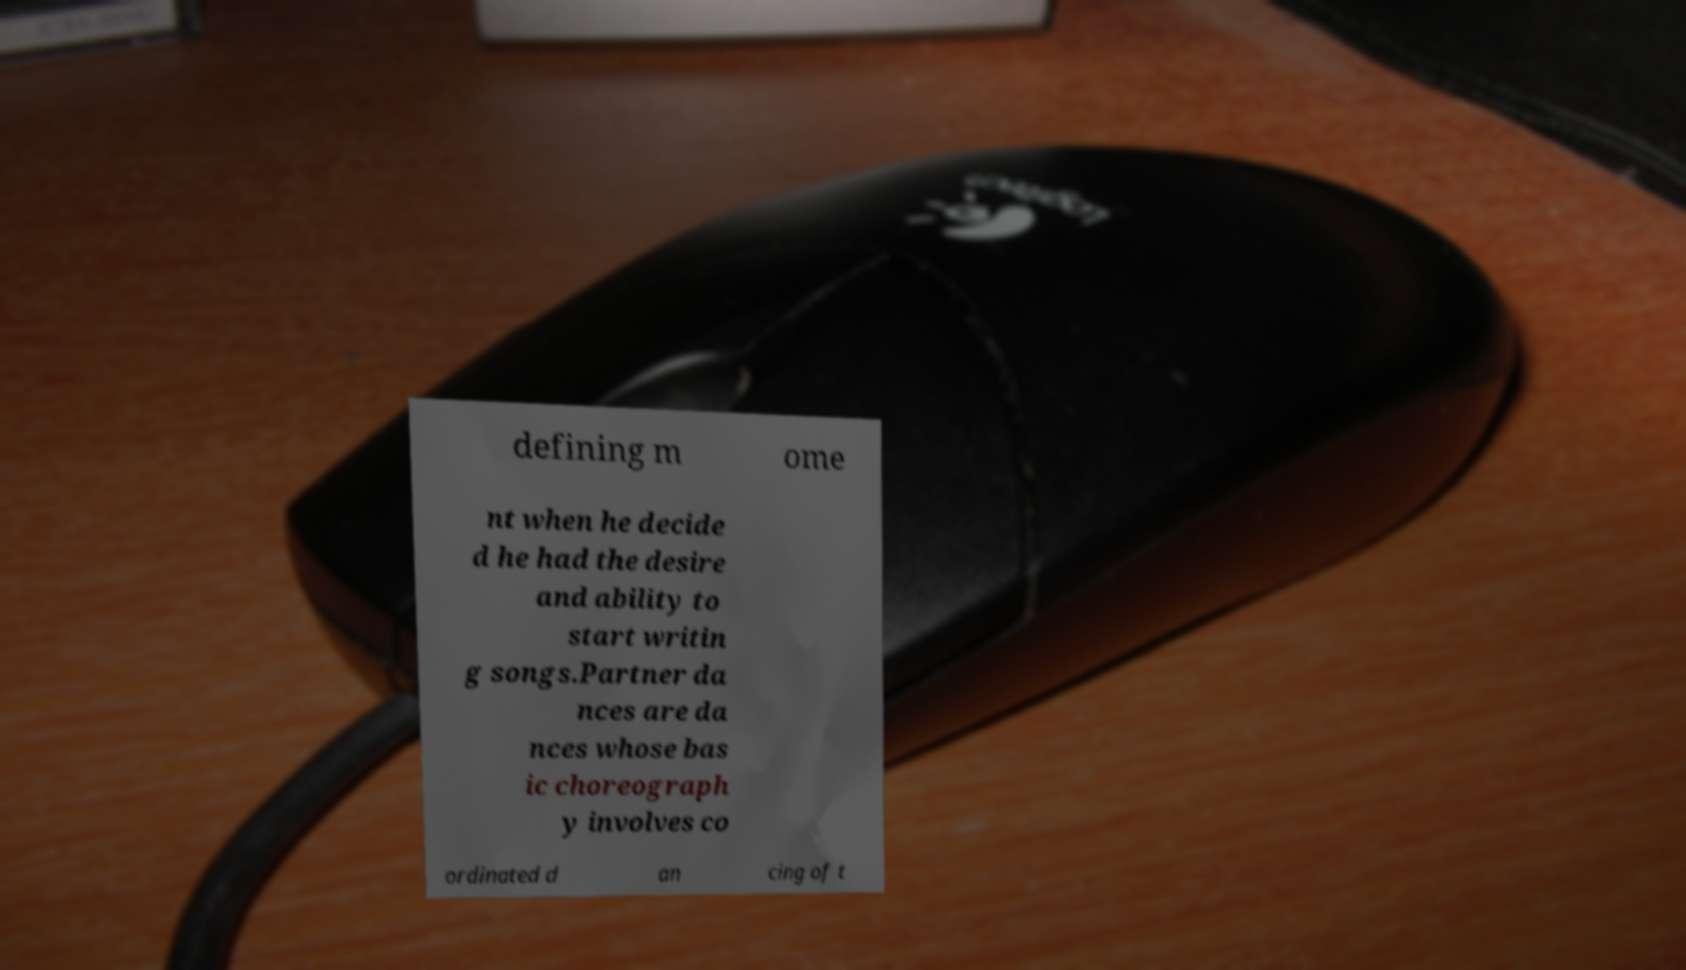For documentation purposes, I need the text within this image transcribed. Could you provide that? defining m ome nt when he decide d he had the desire and ability to start writin g songs.Partner da nces are da nces whose bas ic choreograph y involves co ordinated d an cing of t 